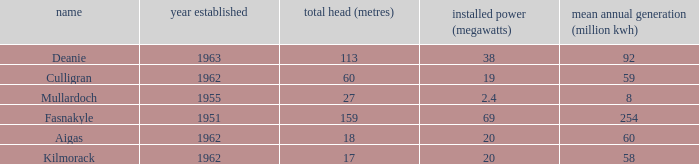What is the Average annual output for Culligran power station with an Installed capacity less than 19? None. 